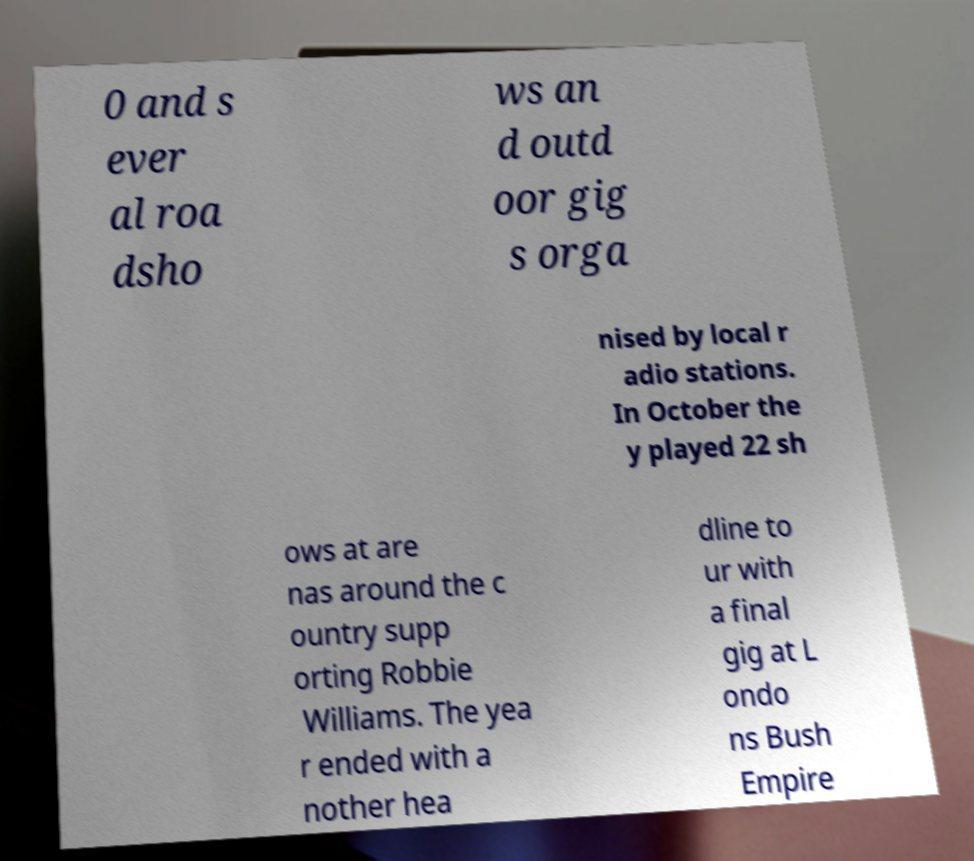Can you read and provide the text displayed in the image?This photo seems to have some interesting text. Can you extract and type it out for me? 0 and s ever al roa dsho ws an d outd oor gig s orga nised by local r adio stations. In October the y played 22 sh ows at are nas around the c ountry supp orting Robbie Williams. The yea r ended with a nother hea dline to ur with a final gig at L ondo ns Bush Empire 